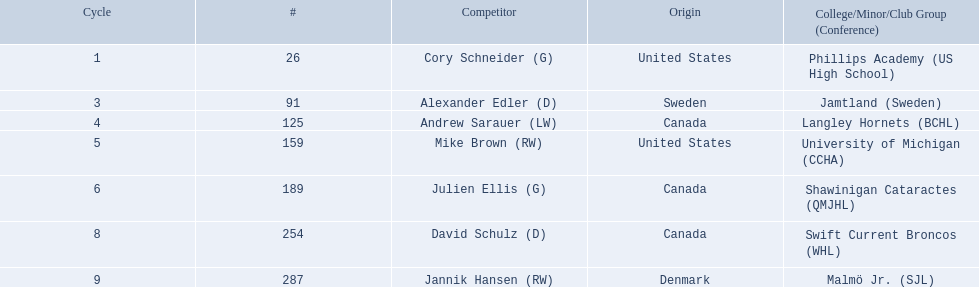Who are all the players? Cory Schneider (G), Alexander Edler (D), Andrew Sarauer (LW), Mike Brown (RW), Julien Ellis (G), David Schulz (D), Jannik Hansen (RW). What is the nationality of each player? United States, Sweden, Canada, United States, Canada, Canada, Denmark. Where did they attend school? Phillips Academy (US High School), Jamtland (Sweden), Langley Hornets (BCHL), University of Michigan (CCHA), Shawinigan Cataractes (QMJHL), Swift Current Broncos (WHL), Malmö Jr. (SJL). Which player attended langley hornets? Andrew Sarauer (LW). 